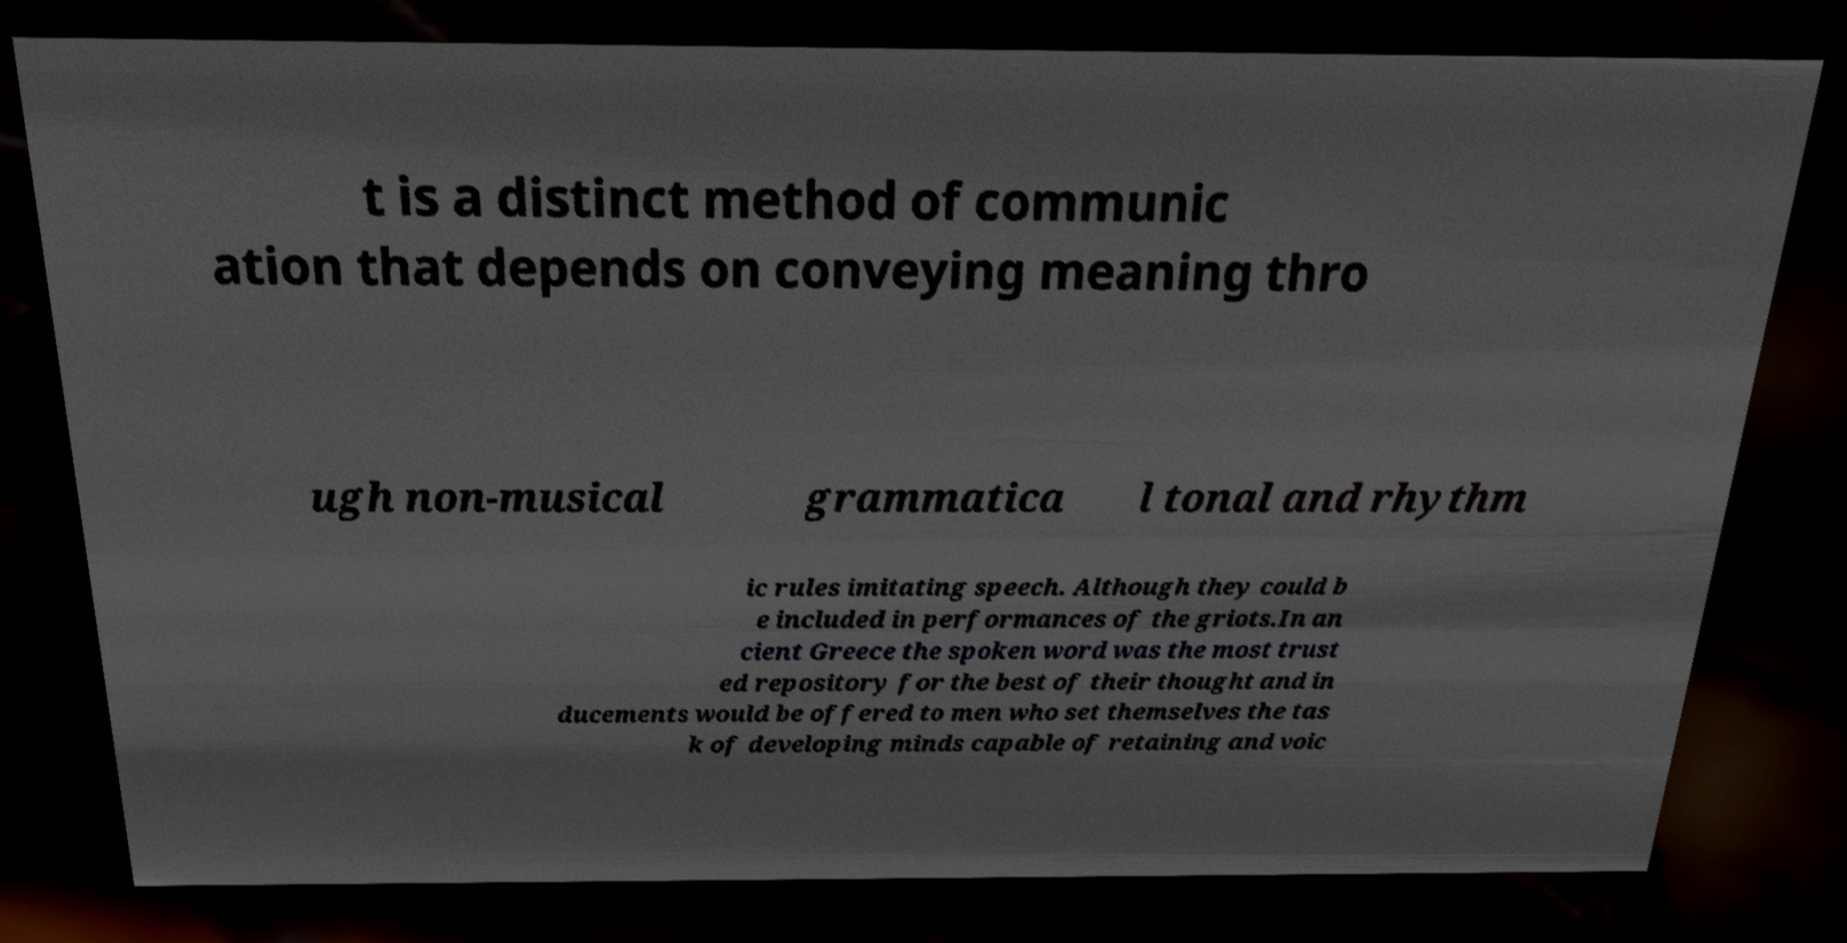Please read and relay the text visible in this image. What does it say? t is a distinct method of communic ation that depends on conveying meaning thro ugh non-musical grammatica l tonal and rhythm ic rules imitating speech. Although they could b e included in performances of the griots.In an cient Greece the spoken word was the most trust ed repository for the best of their thought and in ducements would be offered to men who set themselves the tas k of developing minds capable of retaining and voic 